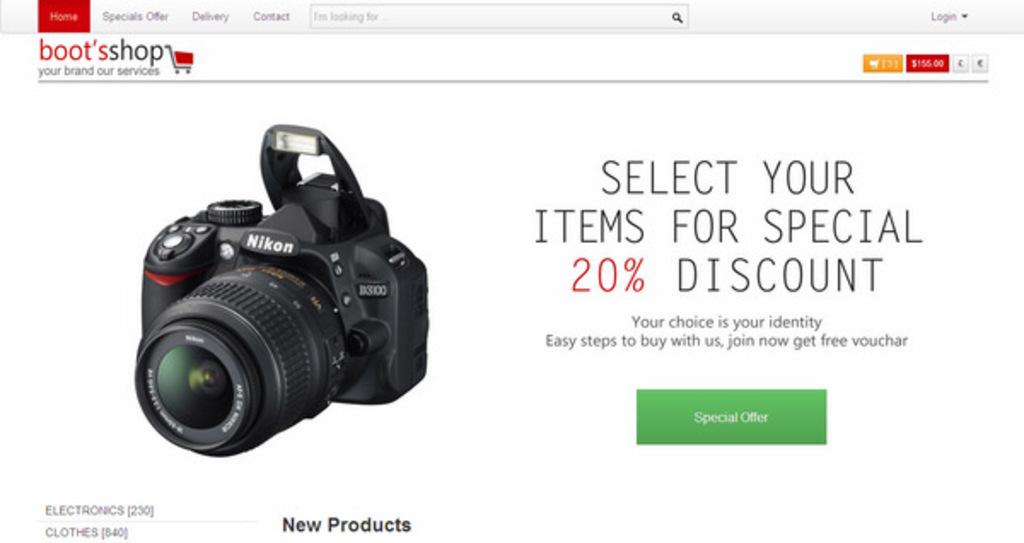What object is located in the left corner of the image? There is a camera in the left corner of the image. What can be seen above the camera in the image? There is something written above the camera. What can be seen below the camera in the image? There is something written below the camera. What can be seen beside the camera in the image? There is something written beside the camera. How does the camera feel about going on vacation in the image? The camera is an inanimate object and does not have feelings or emotions, so it cannot feel regret or any other emotion. 